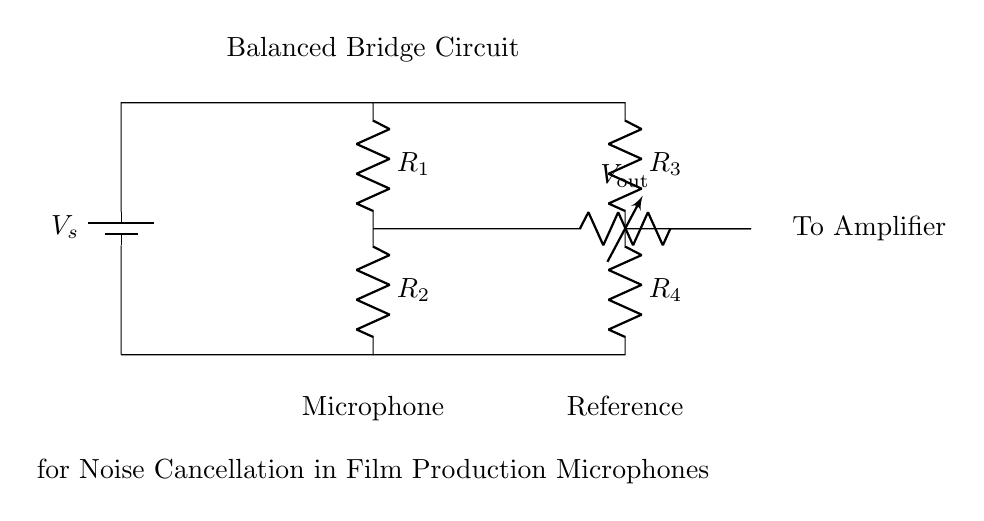What components are present in the circuit? The circuit includes a voltage source, resistors R1, R2, R3, R4, and a voltage reader, V_out. Each element contributes to the function of the balanced bridge circuit.
Answer: voltage source, R1, R2, R3, R4, V_out What is the function of the voltage source in this circuit? The voltage source provides the necessary electrical energy to establish an electric potential across the components, enabling the operation of the bridge circuit.
Answer: provides electrical energy How many resistors are used in this circuit? There are four resistors labeled R1, R2, R3, and R4, which are crucial for balancing the bridge and ensuring noise cancellation.
Answer: four What does V_out represent in the diagram? V_out represents the output voltage that can be measured, which is crucial for determining if the bridge is balanced and for further amplification.
Answer: output voltage Why is this circuit termed a 'balanced bridge'? The circuit is called a balanced bridge because it uses a configuration where the output voltage is zero when the resistors are matched, effectively canceling noise and maximizing desired signals.
Answer: balanced bridge How does this configuration help in noise cancellation for microphones? By balancing the resistors appropriately, the circuit minimizes the impact of external noise, allowing only the audio signal from the microphone to pass through to the amplifier with less interference.
Answer: minimizes noise interference 